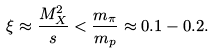Convert formula to latex. <formula><loc_0><loc_0><loc_500><loc_500>\xi \approx \frac { M _ { X } ^ { 2 } } { s } < \frac { m _ { \pi } } { m _ { p } } \approx 0 . 1 - 0 . 2 .</formula> 